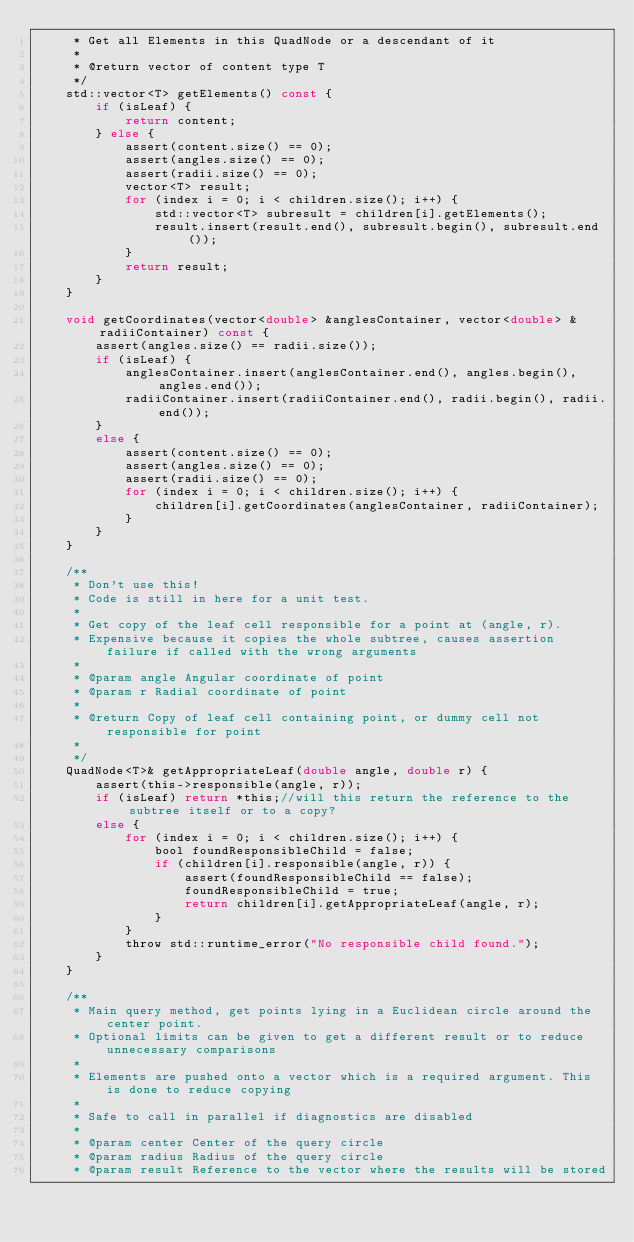Convert code to text. <code><loc_0><loc_0><loc_500><loc_500><_C_>	 * Get all Elements in this QuadNode or a descendant of it
	 *
	 * @return vector of content type T
	 */
	std::vector<T> getElements() const {
		if (isLeaf) {
			return content;
		} else {
			assert(content.size() == 0);
			assert(angles.size() == 0);
			assert(radii.size() == 0);
			vector<T> result;
			for (index i = 0; i < children.size(); i++) {
				std::vector<T> subresult = children[i].getElements();
				result.insert(result.end(), subresult.begin(), subresult.end());
			}
			return result;
		}
	}

	void getCoordinates(vector<double> &anglesContainer, vector<double> &radiiContainer) const {
		assert(angles.size() == radii.size());
		if (isLeaf) {
			anglesContainer.insert(anglesContainer.end(), angles.begin(), angles.end());
			radiiContainer.insert(radiiContainer.end(), radii.begin(), radii.end());
		}
		else {
			assert(content.size() == 0);
			assert(angles.size() == 0);
			assert(radii.size() == 0);
			for (index i = 0; i < children.size(); i++) {
				children[i].getCoordinates(anglesContainer, radiiContainer);
			}
		}
	}

	/**
	 * Don't use this!
	 * Code is still in here for a unit test.
	 *
	 * Get copy of the leaf cell responsible for a point at (angle, r).
	 * Expensive because it copies the whole subtree, causes assertion failure if called with the wrong arguments
	 *
	 * @param angle Angular coordinate of point
	 * @param r Radial coordinate of point
	 *
	 * @return Copy of leaf cell containing point, or dummy cell not responsible for point
	 *
	 */
	QuadNode<T>& getAppropriateLeaf(double angle, double r) {
		assert(this->responsible(angle, r));
		if (isLeaf) return *this;//will this return the reference to the subtree itself or to a copy?
		else {
			for (index i = 0; i < children.size(); i++) {
				bool foundResponsibleChild = false;
				if (children[i].responsible(angle, r)) {
					assert(foundResponsibleChild == false);
					foundResponsibleChild = true;
					return children[i].getAppropriateLeaf(angle, r);
				}
			}
			throw std::runtime_error("No responsible child found.");
		}
	}

	/**
	 * Main query method, get points lying in a Euclidean circle around the center point.
	 * Optional limits can be given to get a different result or to reduce unnecessary comparisons
	 *
	 * Elements are pushed onto a vector which is a required argument. This is done to reduce copying
	 *
	 * Safe to call in parallel if diagnostics are disabled
	 *
	 * @param center Center of the query circle
	 * @param radius Radius of the query circle
	 * @param result Reference to the vector where the results will be stored</code> 